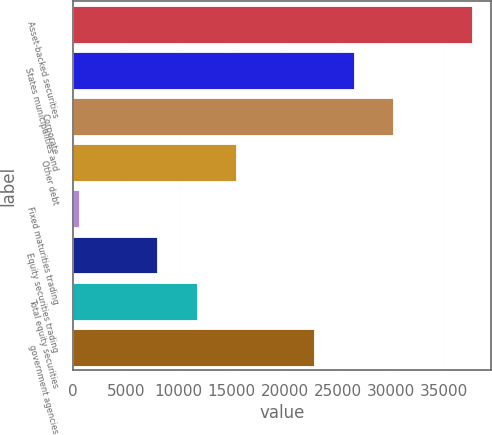Convert chart to OTSL. <chart><loc_0><loc_0><loc_500><loc_500><bar_chart><fcel>Asset-backed securities<fcel>States municipalities and<fcel>Corporate<fcel>Other debt<fcel>Fixed maturities trading<fcel>Equity securities trading<fcel>Total equity securities<fcel>government agencies<nl><fcel>37570<fcel>26473.6<fcel>30172.4<fcel>15377.2<fcel>582<fcel>7979.6<fcel>11678.4<fcel>22774.8<nl></chart> 